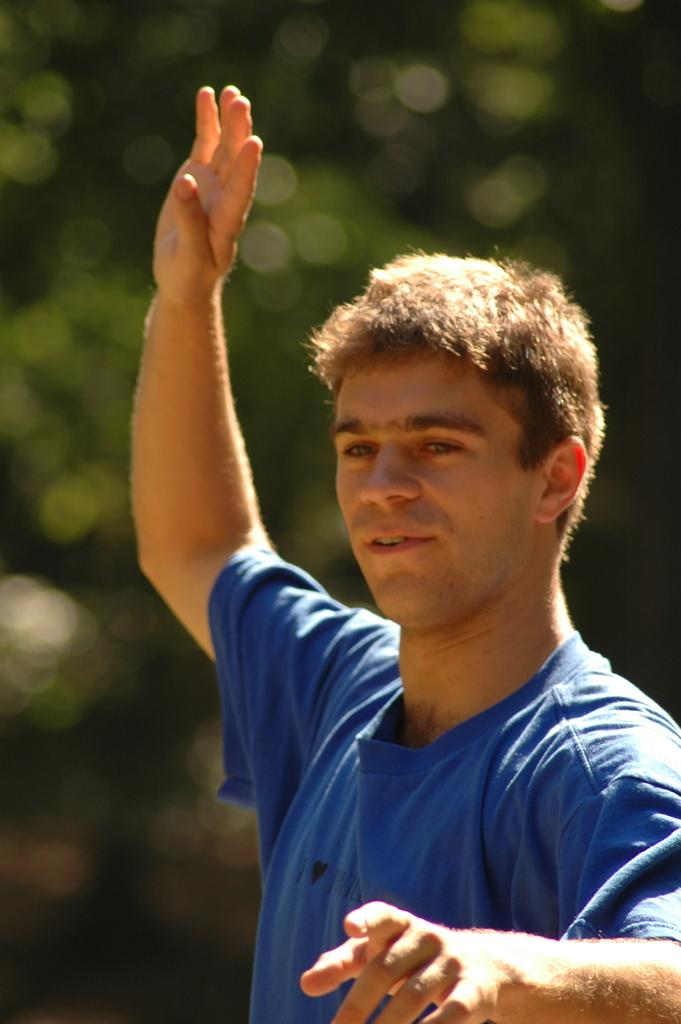Who is the main subject in the image? There is a man in the image. What is the man wearing? The man is wearing a blue t-shirt. Where is the man positioned in the image? The man is standing in the front. What can be seen behind the man in the image? There is a green blur background in the image. What type of payment is being made in the image? There is no payment being made in the image; it features a man standing in front of a green blur background. What type of stew is being prepared in the image? There is no stew or cooking activity present in the image. 